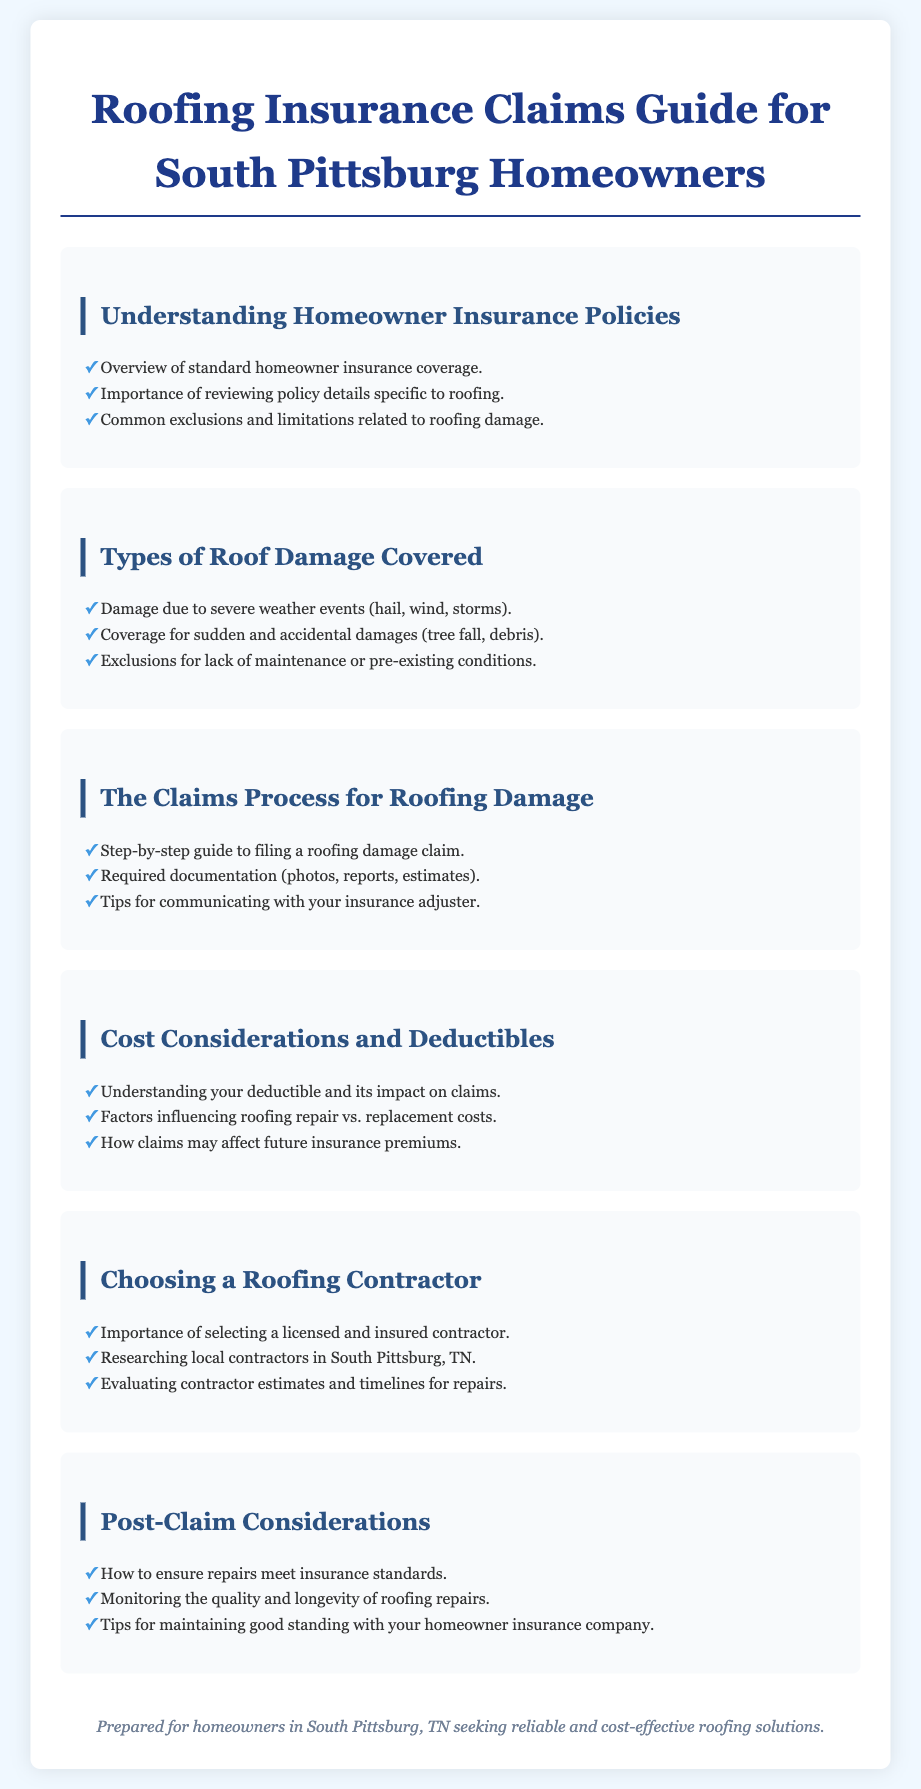What is the title of the document? The title appears at the top and is "Roofing Insurance Claims Guide for South Pittsburg Homeowners."
Answer: Roofing Insurance Claims Guide for South Pittsburg Homeowners How many sections are in the document? The document contains six distinct sections outlined in the content.
Answer: Six What types of events cause roof damage that are covered? The document lists specific severe weather events that can cause damage, including hail, wind, and storms.
Answer: Severe weather events What is the first step in filing a roofing damage claim? The first step is detailed in the claims process section as a step-by-step guide to filing a roofing damage claim.
Answer: Filing a roofing damage claim What factors influence the costs of roofing repair vs. replacement? The document mentions that various factors influence costs, which are discussed within the cost considerations section.
Answer: Factors influencing costs What should you monitor after repairs are completed? The document suggests monitoring the quality and longevity of roofing repairs after the claim is settled.
Answer: Quality and longevity of repairs What is the importance of selecting a certain type of contractor? The document highlights the necessity of choosing a licensed and insured contractor for roofing work.
Answer: Licensed and insured contractor What should you ensure regarding repairs to meet insurance standards? The document emphasizes the importance of ensuring that repairs meet the standards set by the insurance company.
Answer: Repairs meet insurance standards 